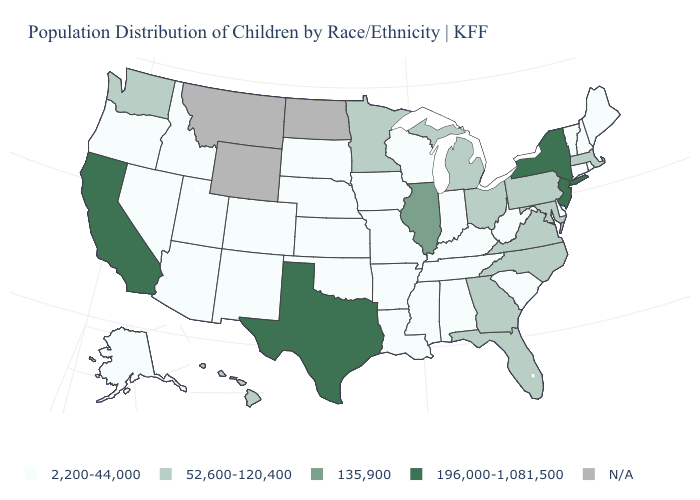Does the first symbol in the legend represent the smallest category?
Give a very brief answer. Yes. What is the value of West Virginia?
Keep it brief. 2,200-44,000. What is the value of Kentucky?
Concise answer only. 2,200-44,000. What is the value of Maryland?
Concise answer only. 52,600-120,400. Name the states that have a value in the range 135,900?
Quick response, please. Illinois. Name the states that have a value in the range 52,600-120,400?
Quick response, please. Florida, Georgia, Hawaii, Maryland, Massachusetts, Michigan, Minnesota, North Carolina, Ohio, Pennsylvania, Virginia, Washington. Does Hawaii have the highest value in the USA?
Quick response, please. No. Name the states that have a value in the range N/A?
Answer briefly. Montana, North Dakota, Wyoming. Among the states that border Oregon , does Washington have the highest value?
Write a very short answer. No. What is the value of Arkansas?
Short answer required. 2,200-44,000. Does New York have the lowest value in the USA?
Keep it brief. No. What is the value of Rhode Island?
Short answer required. 2,200-44,000. Name the states that have a value in the range 196,000-1,081,500?
Concise answer only. California, New Jersey, New York, Texas. 